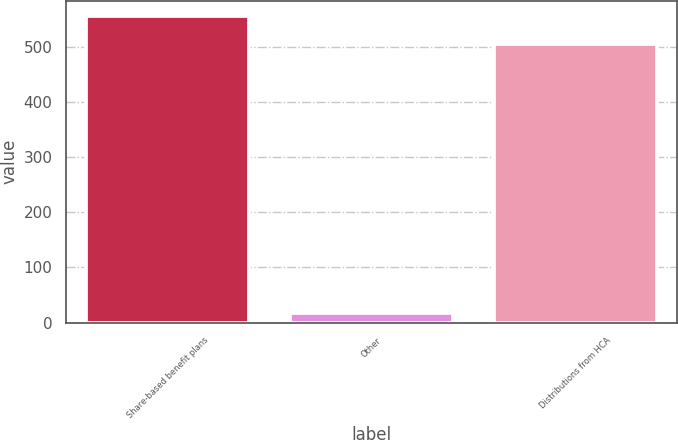Convert chart. <chart><loc_0><loc_0><loc_500><loc_500><bar_chart><fcel>Share-based benefit plans<fcel>Other<fcel>Distributions from HCA<nl><fcel>555.5<fcel>18<fcel>505<nl></chart> 